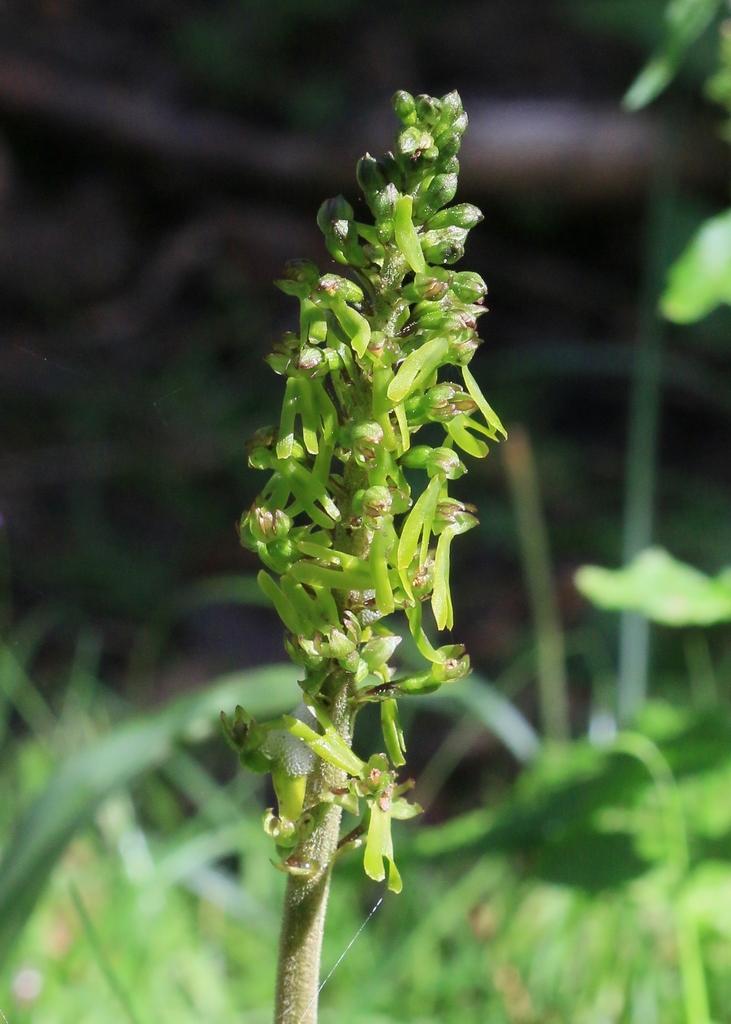In one or two sentences, can you explain what this image depicts? In this picture we can see a plant, some grass and leaves. Background is blurry. 